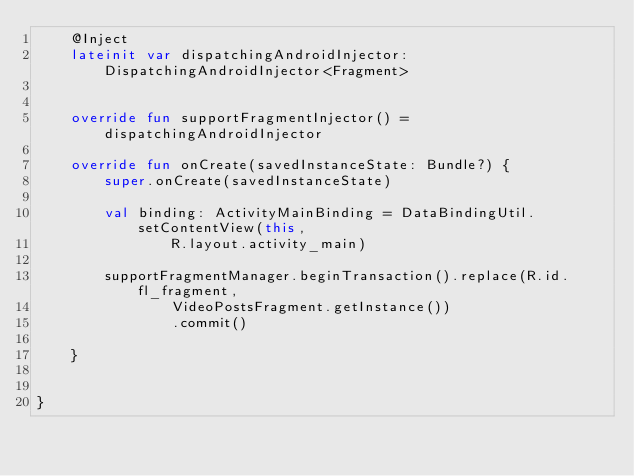Convert code to text. <code><loc_0><loc_0><loc_500><loc_500><_Kotlin_>    @Inject
    lateinit var dispatchingAndroidInjector: DispatchingAndroidInjector<Fragment>


    override fun supportFragmentInjector() = dispatchingAndroidInjector

    override fun onCreate(savedInstanceState: Bundle?) {
        super.onCreate(savedInstanceState)

        val binding: ActivityMainBinding = DataBindingUtil.setContentView(this,
                R.layout.activity_main)

        supportFragmentManager.beginTransaction().replace(R.id.fl_fragment,
                VideoPostsFragment.getInstance())
                .commit()

    }


}</code> 